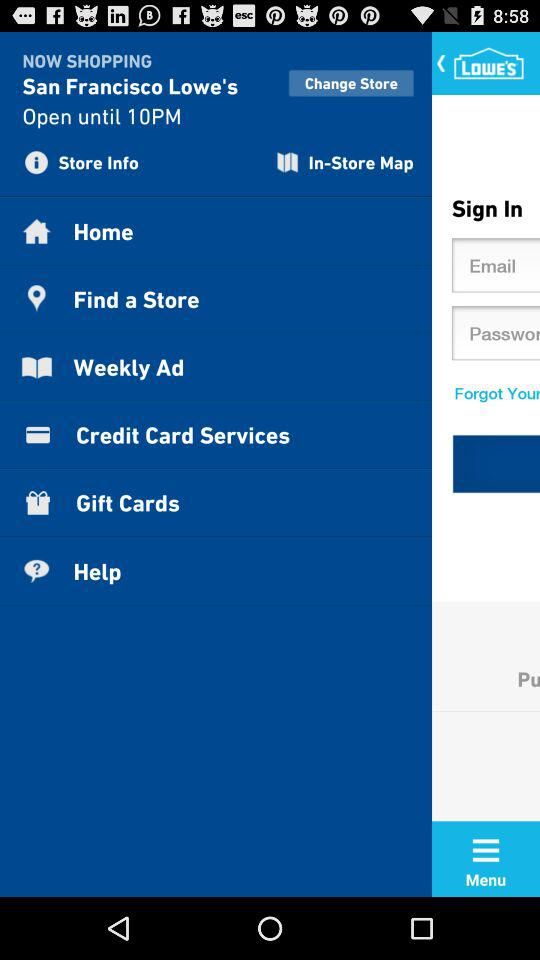How long is it open? It is open until 10 PM. 